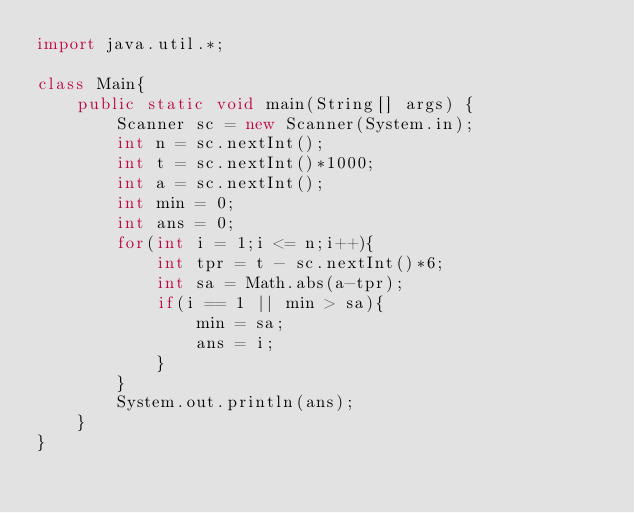Convert code to text. <code><loc_0><loc_0><loc_500><loc_500><_Java_>import java.util.*;

class Main{
    public static void main(String[] args) {
        Scanner sc = new Scanner(System.in);
        int n = sc.nextInt();
        int t = sc.nextInt()*1000;
        int a = sc.nextInt();
        int min = 0;
        int ans = 0;
        for(int i = 1;i <= n;i++){
            int tpr = t - sc.nextInt()*6;
            int sa = Math.abs(a-tpr);
            if(i == 1 || min > sa){
                min = sa;
                ans = i;
            }
        }
        System.out.println(ans);
    }
}</code> 